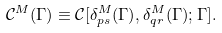<formula> <loc_0><loc_0><loc_500><loc_500>\mathcal { C } ^ { M } ( { \Gamma } ) \equiv \mathcal { C } [ \delta _ { p s } ^ { M } ( { \Gamma } ) , \delta _ { q r } ^ { M } ( { \Gamma } ) ; { \Gamma } ] .</formula> 